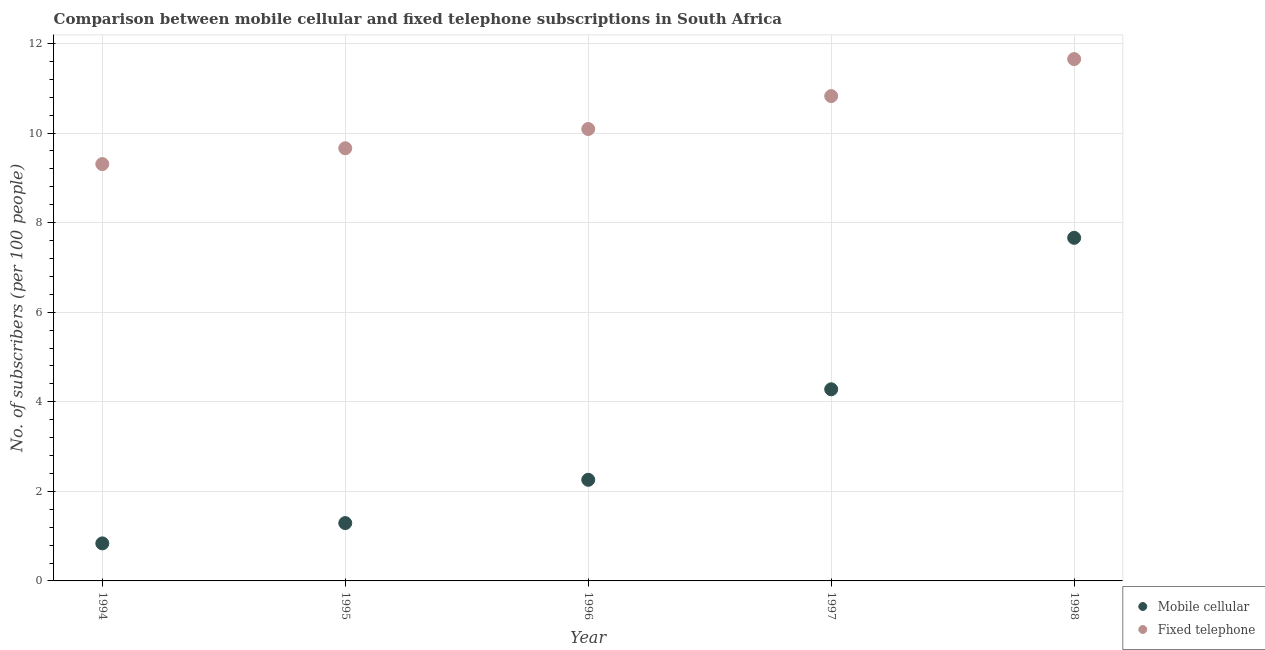What is the number of mobile cellular subscribers in 1997?
Provide a short and direct response. 4.28. Across all years, what is the maximum number of mobile cellular subscribers?
Make the answer very short. 7.66. Across all years, what is the minimum number of mobile cellular subscribers?
Provide a short and direct response. 0.84. In which year was the number of fixed telephone subscribers maximum?
Offer a terse response. 1998. What is the total number of fixed telephone subscribers in the graph?
Offer a terse response. 51.54. What is the difference between the number of mobile cellular subscribers in 1996 and that in 1998?
Your answer should be compact. -5.4. What is the difference between the number of fixed telephone subscribers in 1996 and the number of mobile cellular subscribers in 1998?
Offer a very short reply. 2.43. What is the average number of fixed telephone subscribers per year?
Make the answer very short. 10.31. In the year 1994, what is the difference between the number of mobile cellular subscribers and number of fixed telephone subscribers?
Give a very brief answer. -8.47. In how many years, is the number of mobile cellular subscribers greater than 2?
Offer a terse response. 3. What is the ratio of the number of fixed telephone subscribers in 1994 to that in 1998?
Make the answer very short. 0.8. Is the number of fixed telephone subscribers in 1994 less than that in 1998?
Provide a short and direct response. Yes. What is the difference between the highest and the second highest number of mobile cellular subscribers?
Offer a very short reply. 3.38. What is the difference between the highest and the lowest number of mobile cellular subscribers?
Offer a terse response. 6.82. Does the number of fixed telephone subscribers monotonically increase over the years?
Offer a terse response. Yes. Is the number of fixed telephone subscribers strictly greater than the number of mobile cellular subscribers over the years?
Keep it short and to the point. Yes. Are the values on the major ticks of Y-axis written in scientific E-notation?
Keep it short and to the point. No. Does the graph contain any zero values?
Your answer should be compact. No. Does the graph contain grids?
Provide a short and direct response. Yes. How are the legend labels stacked?
Offer a terse response. Vertical. What is the title of the graph?
Ensure brevity in your answer.  Comparison between mobile cellular and fixed telephone subscriptions in South Africa. What is the label or title of the Y-axis?
Your response must be concise. No. of subscribers (per 100 people). What is the No. of subscribers (per 100 people) in Mobile cellular in 1994?
Provide a short and direct response. 0.84. What is the No. of subscribers (per 100 people) in Fixed telephone in 1994?
Offer a very short reply. 9.31. What is the No. of subscribers (per 100 people) in Mobile cellular in 1995?
Your response must be concise. 1.29. What is the No. of subscribers (per 100 people) in Fixed telephone in 1995?
Offer a very short reply. 9.66. What is the No. of subscribers (per 100 people) in Mobile cellular in 1996?
Your answer should be compact. 2.26. What is the No. of subscribers (per 100 people) in Fixed telephone in 1996?
Offer a very short reply. 10.09. What is the No. of subscribers (per 100 people) of Mobile cellular in 1997?
Offer a terse response. 4.28. What is the No. of subscribers (per 100 people) of Fixed telephone in 1997?
Ensure brevity in your answer.  10.83. What is the No. of subscribers (per 100 people) in Mobile cellular in 1998?
Make the answer very short. 7.66. What is the No. of subscribers (per 100 people) in Fixed telephone in 1998?
Your answer should be compact. 11.65. Across all years, what is the maximum No. of subscribers (per 100 people) of Mobile cellular?
Ensure brevity in your answer.  7.66. Across all years, what is the maximum No. of subscribers (per 100 people) in Fixed telephone?
Ensure brevity in your answer.  11.65. Across all years, what is the minimum No. of subscribers (per 100 people) of Mobile cellular?
Your response must be concise. 0.84. Across all years, what is the minimum No. of subscribers (per 100 people) in Fixed telephone?
Ensure brevity in your answer.  9.31. What is the total No. of subscribers (per 100 people) in Mobile cellular in the graph?
Your answer should be very brief. 16.33. What is the total No. of subscribers (per 100 people) in Fixed telephone in the graph?
Provide a short and direct response. 51.54. What is the difference between the No. of subscribers (per 100 people) of Mobile cellular in 1994 and that in 1995?
Keep it short and to the point. -0.45. What is the difference between the No. of subscribers (per 100 people) of Fixed telephone in 1994 and that in 1995?
Provide a short and direct response. -0.35. What is the difference between the No. of subscribers (per 100 people) of Mobile cellular in 1994 and that in 1996?
Keep it short and to the point. -1.42. What is the difference between the No. of subscribers (per 100 people) of Fixed telephone in 1994 and that in 1996?
Your answer should be compact. -0.78. What is the difference between the No. of subscribers (per 100 people) in Mobile cellular in 1994 and that in 1997?
Make the answer very short. -3.44. What is the difference between the No. of subscribers (per 100 people) in Fixed telephone in 1994 and that in 1997?
Offer a terse response. -1.52. What is the difference between the No. of subscribers (per 100 people) in Mobile cellular in 1994 and that in 1998?
Provide a succinct answer. -6.82. What is the difference between the No. of subscribers (per 100 people) of Fixed telephone in 1994 and that in 1998?
Your answer should be very brief. -2.34. What is the difference between the No. of subscribers (per 100 people) of Mobile cellular in 1995 and that in 1996?
Give a very brief answer. -0.97. What is the difference between the No. of subscribers (per 100 people) in Fixed telephone in 1995 and that in 1996?
Make the answer very short. -0.43. What is the difference between the No. of subscribers (per 100 people) of Mobile cellular in 1995 and that in 1997?
Provide a short and direct response. -2.99. What is the difference between the No. of subscribers (per 100 people) in Fixed telephone in 1995 and that in 1997?
Offer a very short reply. -1.17. What is the difference between the No. of subscribers (per 100 people) of Mobile cellular in 1995 and that in 1998?
Your response must be concise. -6.37. What is the difference between the No. of subscribers (per 100 people) of Fixed telephone in 1995 and that in 1998?
Offer a very short reply. -1.99. What is the difference between the No. of subscribers (per 100 people) in Mobile cellular in 1996 and that in 1997?
Keep it short and to the point. -2.02. What is the difference between the No. of subscribers (per 100 people) of Fixed telephone in 1996 and that in 1997?
Provide a succinct answer. -0.74. What is the difference between the No. of subscribers (per 100 people) in Mobile cellular in 1996 and that in 1998?
Keep it short and to the point. -5.4. What is the difference between the No. of subscribers (per 100 people) of Fixed telephone in 1996 and that in 1998?
Your answer should be very brief. -1.56. What is the difference between the No. of subscribers (per 100 people) in Mobile cellular in 1997 and that in 1998?
Offer a very short reply. -3.38. What is the difference between the No. of subscribers (per 100 people) in Fixed telephone in 1997 and that in 1998?
Ensure brevity in your answer.  -0.83. What is the difference between the No. of subscribers (per 100 people) of Mobile cellular in 1994 and the No. of subscribers (per 100 people) of Fixed telephone in 1995?
Your answer should be very brief. -8.82. What is the difference between the No. of subscribers (per 100 people) of Mobile cellular in 1994 and the No. of subscribers (per 100 people) of Fixed telephone in 1996?
Give a very brief answer. -9.25. What is the difference between the No. of subscribers (per 100 people) of Mobile cellular in 1994 and the No. of subscribers (per 100 people) of Fixed telephone in 1997?
Make the answer very short. -9.99. What is the difference between the No. of subscribers (per 100 people) of Mobile cellular in 1994 and the No. of subscribers (per 100 people) of Fixed telephone in 1998?
Make the answer very short. -10.81. What is the difference between the No. of subscribers (per 100 people) of Mobile cellular in 1995 and the No. of subscribers (per 100 people) of Fixed telephone in 1996?
Offer a very short reply. -8.8. What is the difference between the No. of subscribers (per 100 people) of Mobile cellular in 1995 and the No. of subscribers (per 100 people) of Fixed telephone in 1997?
Ensure brevity in your answer.  -9.53. What is the difference between the No. of subscribers (per 100 people) of Mobile cellular in 1995 and the No. of subscribers (per 100 people) of Fixed telephone in 1998?
Ensure brevity in your answer.  -10.36. What is the difference between the No. of subscribers (per 100 people) in Mobile cellular in 1996 and the No. of subscribers (per 100 people) in Fixed telephone in 1997?
Offer a very short reply. -8.57. What is the difference between the No. of subscribers (per 100 people) of Mobile cellular in 1996 and the No. of subscribers (per 100 people) of Fixed telephone in 1998?
Offer a very short reply. -9.39. What is the difference between the No. of subscribers (per 100 people) in Mobile cellular in 1997 and the No. of subscribers (per 100 people) in Fixed telephone in 1998?
Offer a terse response. -7.37. What is the average No. of subscribers (per 100 people) of Mobile cellular per year?
Provide a succinct answer. 3.27. What is the average No. of subscribers (per 100 people) in Fixed telephone per year?
Offer a very short reply. 10.31. In the year 1994, what is the difference between the No. of subscribers (per 100 people) of Mobile cellular and No. of subscribers (per 100 people) of Fixed telephone?
Give a very brief answer. -8.47. In the year 1995, what is the difference between the No. of subscribers (per 100 people) in Mobile cellular and No. of subscribers (per 100 people) in Fixed telephone?
Offer a very short reply. -8.37. In the year 1996, what is the difference between the No. of subscribers (per 100 people) in Mobile cellular and No. of subscribers (per 100 people) in Fixed telephone?
Offer a terse response. -7.83. In the year 1997, what is the difference between the No. of subscribers (per 100 people) of Mobile cellular and No. of subscribers (per 100 people) of Fixed telephone?
Provide a short and direct response. -6.55. In the year 1998, what is the difference between the No. of subscribers (per 100 people) of Mobile cellular and No. of subscribers (per 100 people) of Fixed telephone?
Your answer should be compact. -3.99. What is the ratio of the No. of subscribers (per 100 people) of Mobile cellular in 1994 to that in 1995?
Keep it short and to the point. 0.65. What is the ratio of the No. of subscribers (per 100 people) in Fixed telephone in 1994 to that in 1995?
Give a very brief answer. 0.96. What is the ratio of the No. of subscribers (per 100 people) in Mobile cellular in 1994 to that in 1996?
Provide a succinct answer. 0.37. What is the ratio of the No. of subscribers (per 100 people) of Fixed telephone in 1994 to that in 1996?
Make the answer very short. 0.92. What is the ratio of the No. of subscribers (per 100 people) of Mobile cellular in 1994 to that in 1997?
Provide a succinct answer. 0.2. What is the ratio of the No. of subscribers (per 100 people) in Fixed telephone in 1994 to that in 1997?
Give a very brief answer. 0.86. What is the ratio of the No. of subscribers (per 100 people) of Mobile cellular in 1994 to that in 1998?
Ensure brevity in your answer.  0.11. What is the ratio of the No. of subscribers (per 100 people) in Fixed telephone in 1994 to that in 1998?
Offer a terse response. 0.8. What is the ratio of the No. of subscribers (per 100 people) in Mobile cellular in 1995 to that in 1996?
Give a very brief answer. 0.57. What is the ratio of the No. of subscribers (per 100 people) of Fixed telephone in 1995 to that in 1996?
Make the answer very short. 0.96. What is the ratio of the No. of subscribers (per 100 people) of Mobile cellular in 1995 to that in 1997?
Offer a terse response. 0.3. What is the ratio of the No. of subscribers (per 100 people) of Fixed telephone in 1995 to that in 1997?
Provide a short and direct response. 0.89. What is the ratio of the No. of subscribers (per 100 people) in Mobile cellular in 1995 to that in 1998?
Give a very brief answer. 0.17. What is the ratio of the No. of subscribers (per 100 people) in Fixed telephone in 1995 to that in 1998?
Offer a terse response. 0.83. What is the ratio of the No. of subscribers (per 100 people) in Mobile cellular in 1996 to that in 1997?
Provide a succinct answer. 0.53. What is the ratio of the No. of subscribers (per 100 people) of Fixed telephone in 1996 to that in 1997?
Provide a short and direct response. 0.93. What is the ratio of the No. of subscribers (per 100 people) of Mobile cellular in 1996 to that in 1998?
Your response must be concise. 0.29. What is the ratio of the No. of subscribers (per 100 people) of Fixed telephone in 1996 to that in 1998?
Your answer should be very brief. 0.87. What is the ratio of the No. of subscribers (per 100 people) in Mobile cellular in 1997 to that in 1998?
Keep it short and to the point. 0.56. What is the ratio of the No. of subscribers (per 100 people) of Fixed telephone in 1997 to that in 1998?
Provide a short and direct response. 0.93. What is the difference between the highest and the second highest No. of subscribers (per 100 people) in Mobile cellular?
Keep it short and to the point. 3.38. What is the difference between the highest and the second highest No. of subscribers (per 100 people) in Fixed telephone?
Your response must be concise. 0.83. What is the difference between the highest and the lowest No. of subscribers (per 100 people) of Mobile cellular?
Provide a short and direct response. 6.82. What is the difference between the highest and the lowest No. of subscribers (per 100 people) of Fixed telephone?
Make the answer very short. 2.34. 